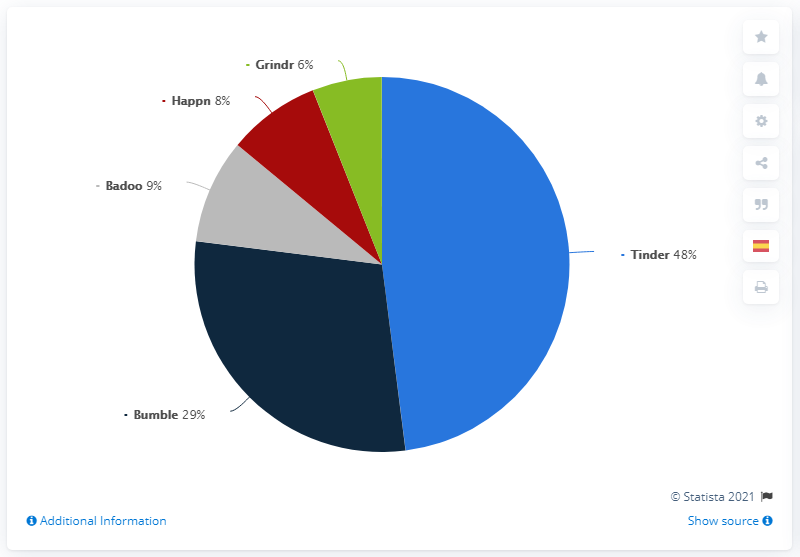Identify some key points in this picture. The most commonly used dating app in Mexico is different from the least used app. The most widely used dating app in Mexico in 2021 is Tinder. 